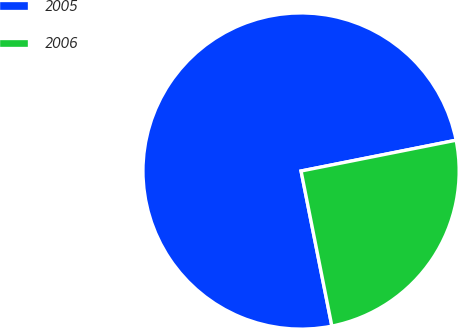Convert chart. <chart><loc_0><loc_0><loc_500><loc_500><pie_chart><fcel>2005<fcel>2006<nl><fcel>75.0%<fcel>25.0%<nl></chart> 